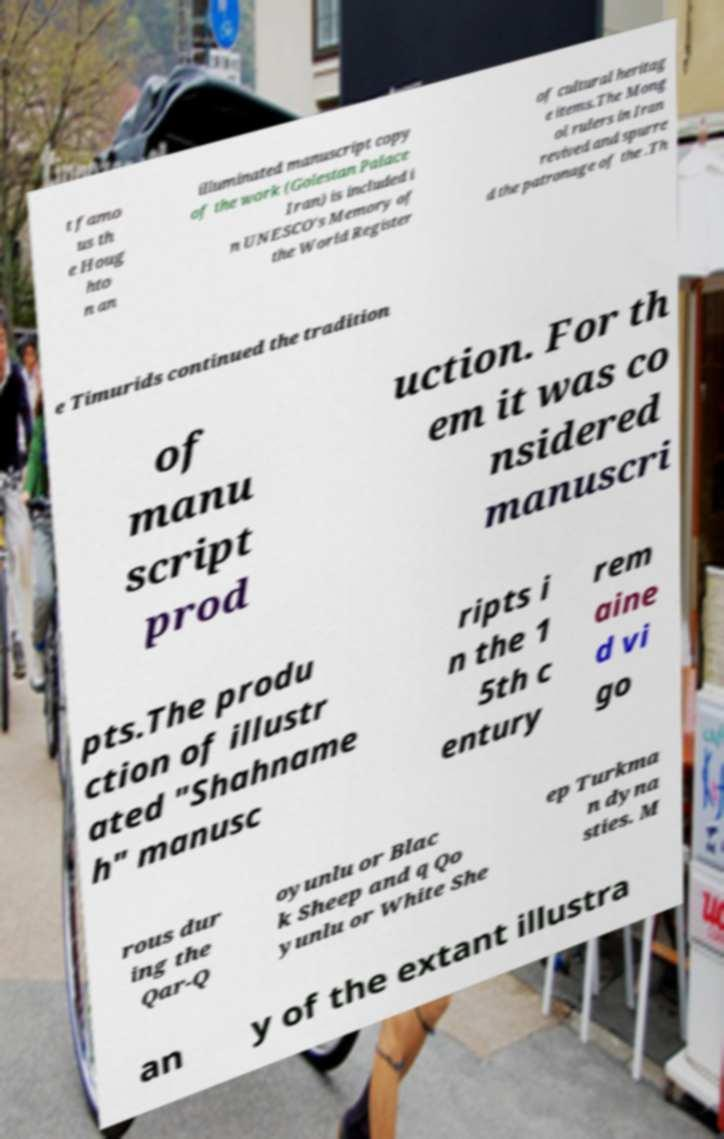There's text embedded in this image that I need extracted. Can you transcribe it verbatim? t famo us th e Houg hto n an illuminated manuscript copy of the work (Golestan Palace Iran) is included i n UNESCO's Memory of the World Register of cultural heritag e items.The Mong ol rulers in Iran revived and spurre d the patronage of the .Th e Timurids continued the tradition of manu script prod uction. For th em it was co nsidered manuscri pts.The produ ction of illustr ated "Shahname h" manusc ripts i n the 1 5th c entury rem aine d vi go rous dur ing the Qar-Q oyunlu or Blac k Sheep and q Qo yunlu or White She ep Turkma n dyna sties. M an y of the extant illustra 